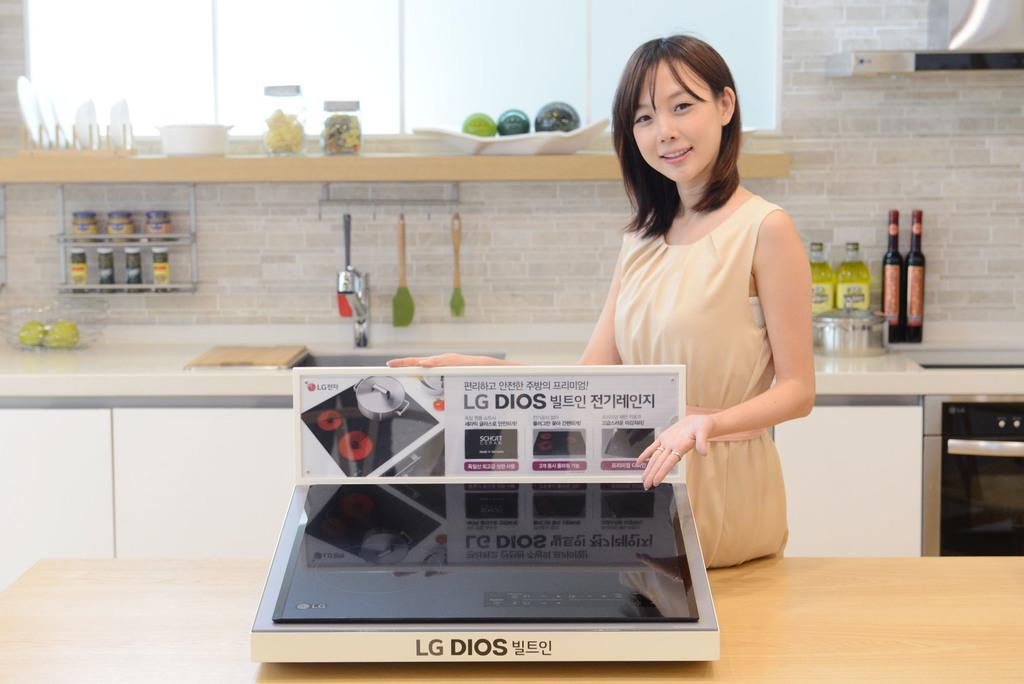<image>
Present a compact description of the photo's key features. A woman is displaying an LG product in a kitchen. 